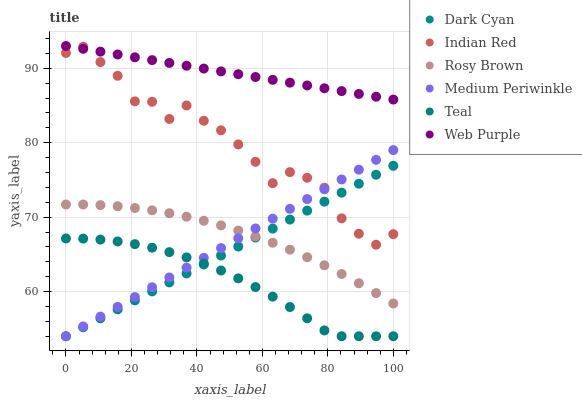Does Teal have the minimum area under the curve?
Answer yes or no. Yes. Does Web Purple have the maximum area under the curve?
Answer yes or no. Yes. Does Rosy Brown have the minimum area under the curve?
Answer yes or no. No. Does Rosy Brown have the maximum area under the curve?
Answer yes or no. No. Is Web Purple the smoothest?
Answer yes or no. Yes. Is Indian Red the roughest?
Answer yes or no. Yes. Is Rosy Brown the smoothest?
Answer yes or no. No. Is Rosy Brown the roughest?
Answer yes or no. No. Does Medium Periwinkle have the lowest value?
Answer yes or no. Yes. Does Rosy Brown have the lowest value?
Answer yes or no. No. Does Web Purple have the highest value?
Answer yes or no. Yes. Does Rosy Brown have the highest value?
Answer yes or no. No. Is Rosy Brown less than Web Purple?
Answer yes or no. Yes. Is Indian Red greater than Rosy Brown?
Answer yes or no. Yes. Does Dark Cyan intersect Teal?
Answer yes or no. Yes. Is Dark Cyan less than Teal?
Answer yes or no. No. Is Dark Cyan greater than Teal?
Answer yes or no. No. Does Rosy Brown intersect Web Purple?
Answer yes or no. No. 